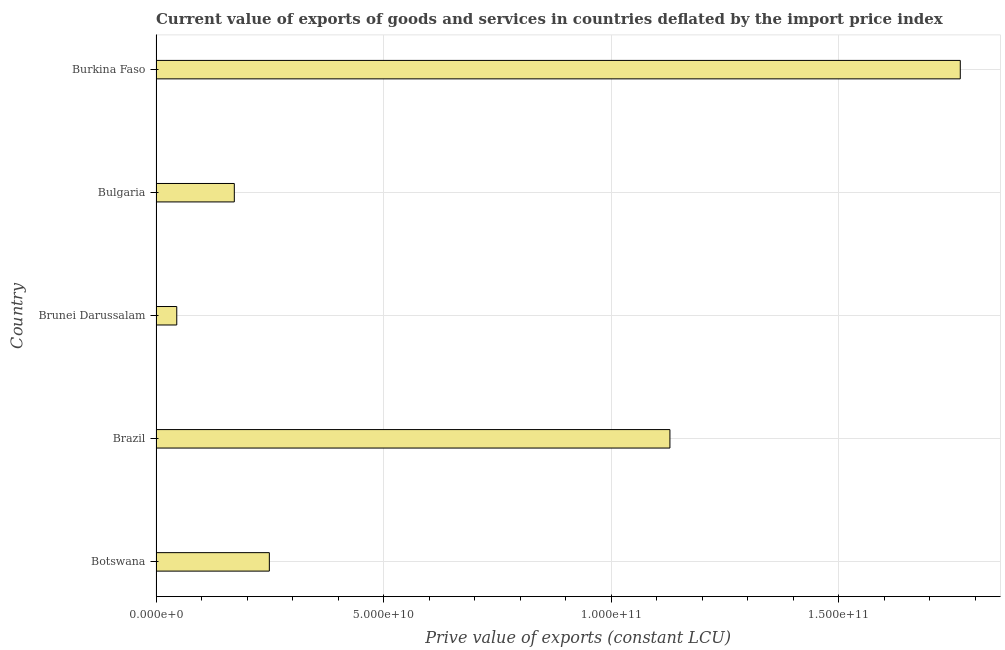Does the graph contain any zero values?
Your answer should be very brief. No. Does the graph contain grids?
Offer a very short reply. Yes. What is the title of the graph?
Keep it short and to the point. Current value of exports of goods and services in countries deflated by the import price index. What is the label or title of the X-axis?
Your answer should be compact. Prive value of exports (constant LCU). What is the label or title of the Y-axis?
Offer a very short reply. Country. What is the price value of exports in Brazil?
Keep it short and to the point. 1.13e+11. Across all countries, what is the maximum price value of exports?
Give a very brief answer. 1.77e+11. Across all countries, what is the minimum price value of exports?
Your answer should be very brief. 4.56e+09. In which country was the price value of exports maximum?
Offer a terse response. Burkina Faso. In which country was the price value of exports minimum?
Your answer should be compact. Brunei Darussalam. What is the sum of the price value of exports?
Your answer should be compact. 3.36e+11. What is the difference between the price value of exports in Brazil and Bulgaria?
Make the answer very short. 9.57e+1. What is the average price value of exports per country?
Offer a very short reply. 6.72e+1. What is the median price value of exports?
Provide a succinct answer. 2.49e+1. What is the ratio of the price value of exports in Brunei Darussalam to that in Burkina Faso?
Make the answer very short. 0.03. Is the price value of exports in Brazil less than that in Burkina Faso?
Offer a very short reply. Yes. Is the difference between the price value of exports in Bulgaria and Burkina Faso greater than the difference between any two countries?
Your answer should be very brief. No. What is the difference between the highest and the second highest price value of exports?
Provide a succinct answer. 6.38e+1. What is the difference between the highest and the lowest price value of exports?
Offer a terse response. 1.72e+11. Are all the bars in the graph horizontal?
Provide a succinct answer. Yes. How many countries are there in the graph?
Offer a terse response. 5. What is the difference between two consecutive major ticks on the X-axis?
Provide a succinct answer. 5.00e+1. What is the Prive value of exports (constant LCU) of Botswana?
Ensure brevity in your answer.  2.49e+1. What is the Prive value of exports (constant LCU) in Brazil?
Your response must be concise. 1.13e+11. What is the Prive value of exports (constant LCU) in Brunei Darussalam?
Your answer should be very brief. 4.56e+09. What is the Prive value of exports (constant LCU) in Bulgaria?
Ensure brevity in your answer.  1.72e+1. What is the Prive value of exports (constant LCU) in Burkina Faso?
Keep it short and to the point. 1.77e+11. What is the difference between the Prive value of exports (constant LCU) in Botswana and Brazil?
Your answer should be very brief. -8.80e+1. What is the difference between the Prive value of exports (constant LCU) in Botswana and Brunei Darussalam?
Your answer should be compact. 2.03e+1. What is the difference between the Prive value of exports (constant LCU) in Botswana and Bulgaria?
Make the answer very short. 7.69e+09. What is the difference between the Prive value of exports (constant LCU) in Botswana and Burkina Faso?
Give a very brief answer. -1.52e+11. What is the difference between the Prive value of exports (constant LCU) in Brazil and Brunei Darussalam?
Ensure brevity in your answer.  1.08e+11. What is the difference between the Prive value of exports (constant LCU) in Brazil and Bulgaria?
Your response must be concise. 9.57e+1. What is the difference between the Prive value of exports (constant LCU) in Brazil and Burkina Faso?
Your answer should be very brief. -6.38e+1. What is the difference between the Prive value of exports (constant LCU) in Brunei Darussalam and Bulgaria?
Provide a short and direct response. -1.26e+1. What is the difference between the Prive value of exports (constant LCU) in Brunei Darussalam and Burkina Faso?
Your answer should be compact. -1.72e+11. What is the difference between the Prive value of exports (constant LCU) in Bulgaria and Burkina Faso?
Ensure brevity in your answer.  -1.59e+11. What is the ratio of the Prive value of exports (constant LCU) in Botswana to that in Brazil?
Keep it short and to the point. 0.22. What is the ratio of the Prive value of exports (constant LCU) in Botswana to that in Brunei Darussalam?
Your response must be concise. 5.46. What is the ratio of the Prive value of exports (constant LCU) in Botswana to that in Bulgaria?
Keep it short and to the point. 1.45. What is the ratio of the Prive value of exports (constant LCU) in Botswana to that in Burkina Faso?
Ensure brevity in your answer.  0.14. What is the ratio of the Prive value of exports (constant LCU) in Brazil to that in Brunei Darussalam?
Offer a terse response. 24.77. What is the ratio of the Prive value of exports (constant LCU) in Brazil to that in Bulgaria?
Provide a succinct answer. 6.56. What is the ratio of the Prive value of exports (constant LCU) in Brazil to that in Burkina Faso?
Provide a succinct answer. 0.64. What is the ratio of the Prive value of exports (constant LCU) in Brunei Darussalam to that in Bulgaria?
Offer a very short reply. 0.27. What is the ratio of the Prive value of exports (constant LCU) in Brunei Darussalam to that in Burkina Faso?
Offer a terse response. 0.03. What is the ratio of the Prive value of exports (constant LCU) in Bulgaria to that in Burkina Faso?
Offer a very short reply. 0.1. 